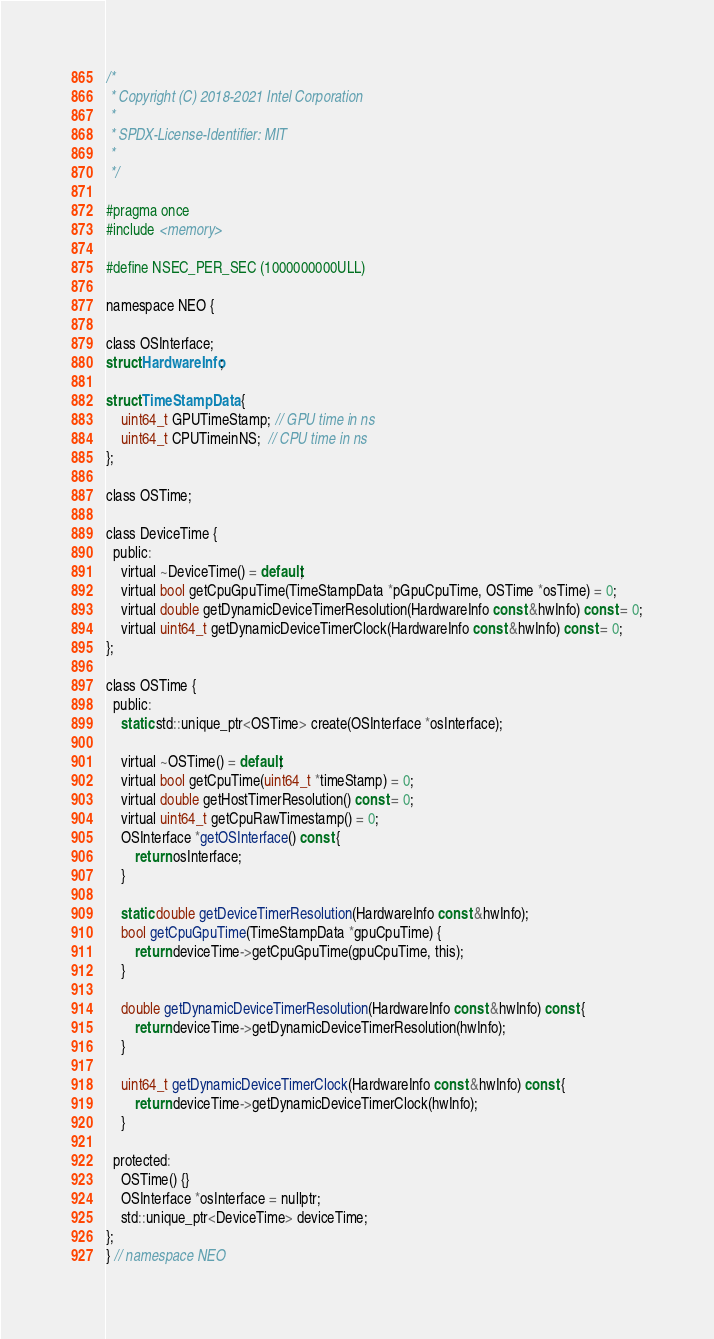Convert code to text. <code><loc_0><loc_0><loc_500><loc_500><_C_>/*
 * Copyright (C) 2018-2021 Intel Corporation
 *
 * SPDX-License-Identifier: MIT
 *
 */

#pragma once
#include <memory>

#define NSEC_PER_SEC (1000000000ULL)

namespace NEO {

class OSInterface;
struct HardwareInfo;

struct TimeStampData {
    uint64_t GPUTimeStamp; // GPU time in ns
    uint64_t CPUTimeinNS;  // CPU time in ns
};

class OSTime;

class DeviceTime {
  public:
    virtual ~DeviceTime() = default;
    virtual bool getCpuGpuTime(TimeStampData *pGpuCpuTime, OSTime *osTime) = 0;
    virtual double getDynamicDeviceTimerResolution(HardwareInfo const &hwInfo) const = 0;
    virtual uint64_t getDynamicDeviceTimerClock(HardwareInfo const &hwInfo) const = 0;
};

class OSTime {
  public:
    static std::unique_ptr<OSTime> create(OSInterface *osInterface);

    virtual ~OSTime() = default;
    virtual bool getCpuTime(uint64_t *timeStamp) = 0;
    virtual double getHostTimerResolution() const = 0;
    virtual uint64_t getCpuRawTimestamp() = 0;
    OSInterface *getOSInterface() const {
        return osInterface;
    }

    static double getDeviceTimerResolution(HardwareInfo const &hwInfo);
    bool getCpuGpuTime(TimeStampData *gpuCpuTime) {
        return deviceTime->getCpuGpuTime(gpuCpuTime, this);
    }

    double getDynamicDeviceTimerResolution(HardwareInfo const &hwInfo) const {
        return deviceTime->getDynamicDeviceTimerResolution(hwInfo);
    }

    uint64_t getDynamicDeviceTimerClock(HardwareInfo const &hwInfo) const {
        return deviceTime->getDynamicDeviceTimerClock(hwInfo);
    }

  protected:
    OSTime() {}
    OSInterface *osInterface = nullptr;
    std::unique_ptr<DeviceTime> deviceTime;
};
} // namespace NEO
</code> 